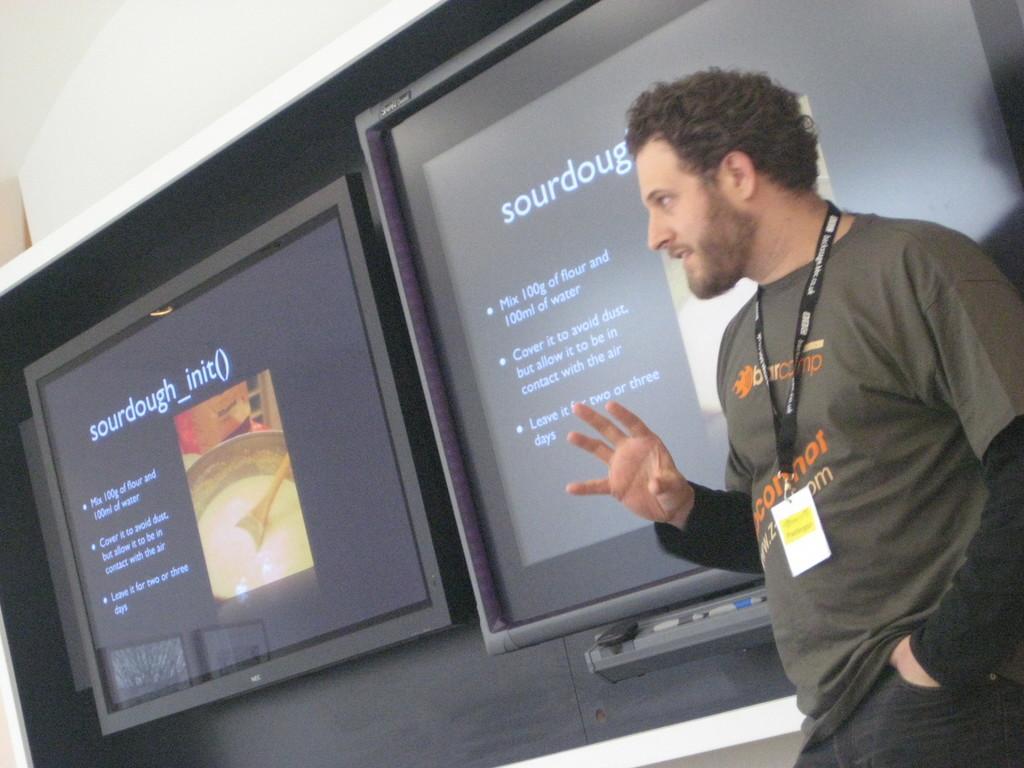Please provide a concise description of this image. In this picture there is a man standing and talking. At the back there are screens on the wall and there is text on the screens and there is a remote on the stand. At the top there is a wall and there is a picture of a bowl and spoon on the screen. 